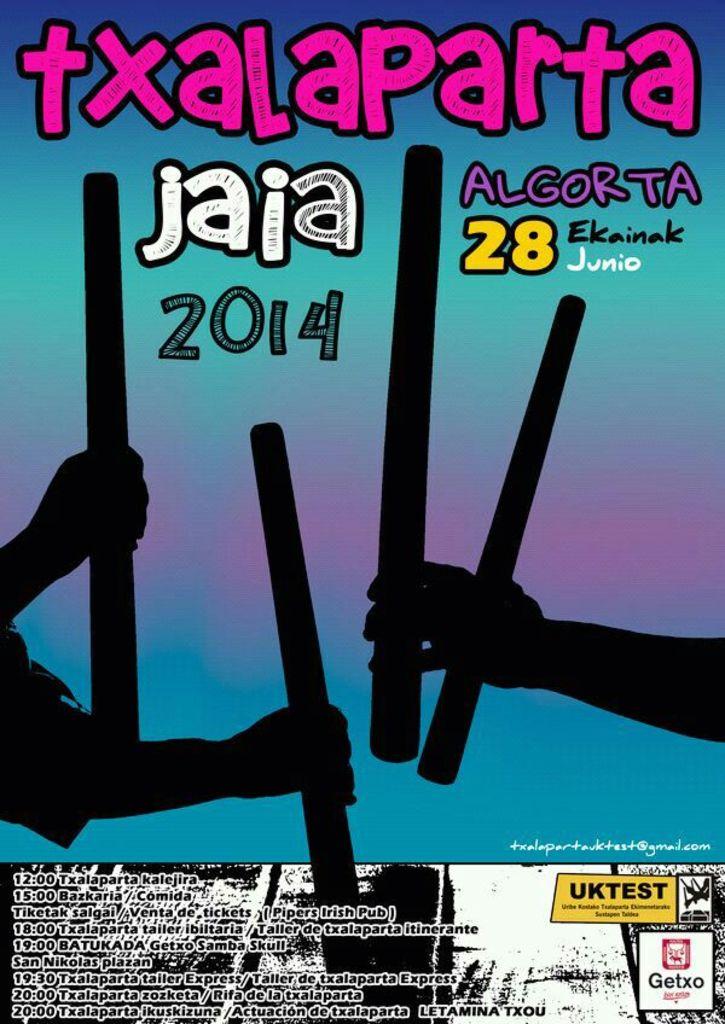What's the year mentioned?
Offer a terse response. 2014. 